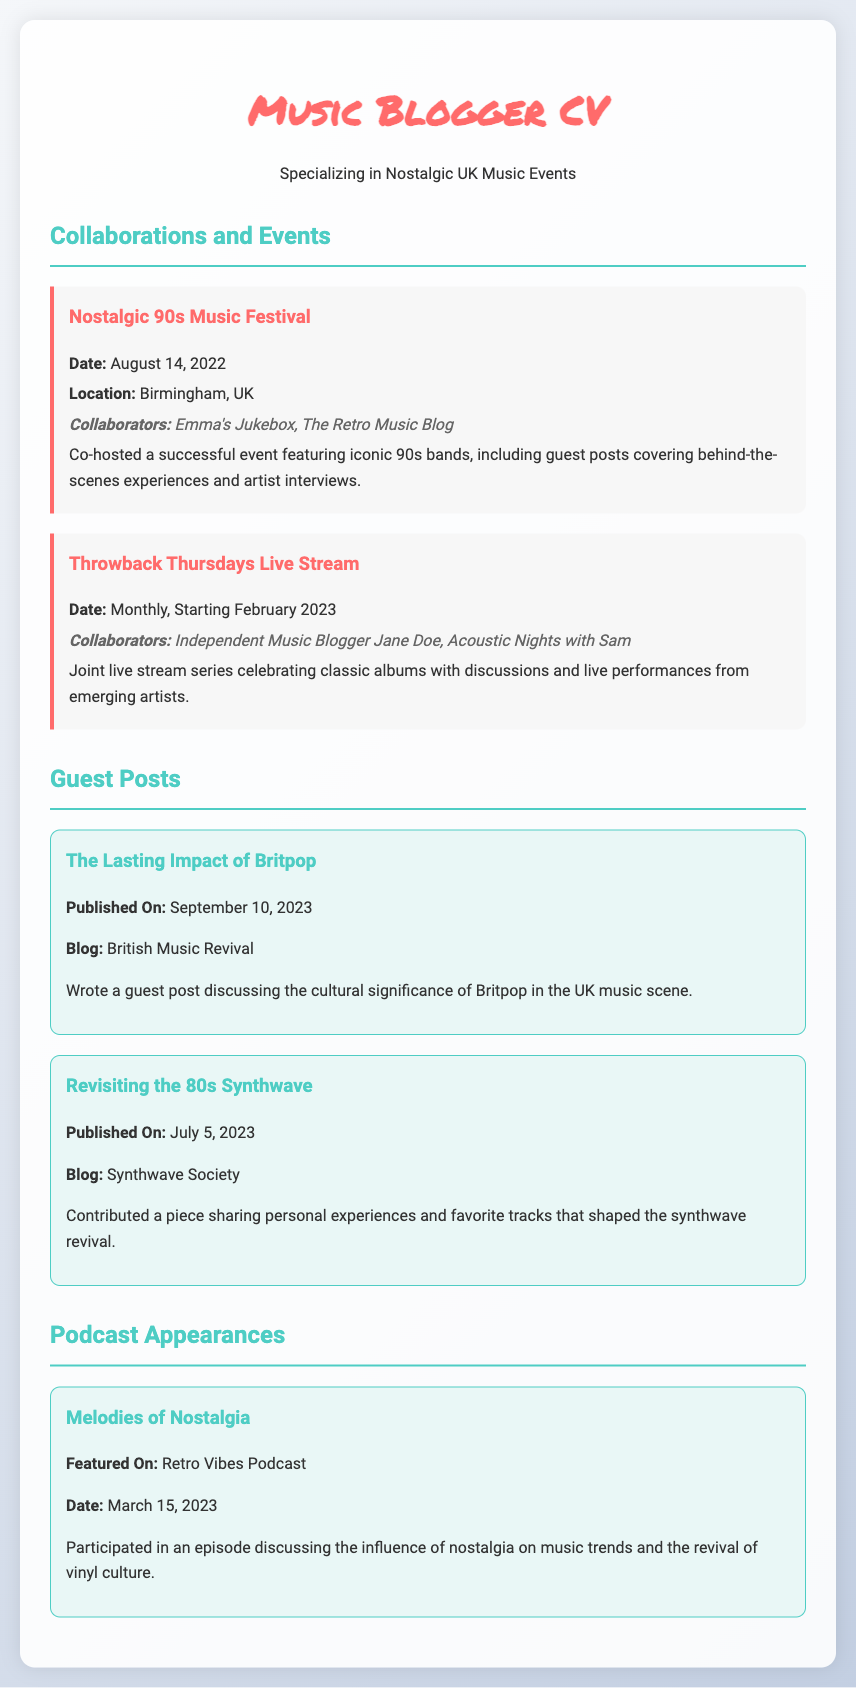What is the title of the document? The title of the document is the main heading at the top, which is "Music Blogger CV - Nostalgic UK Events."
Answer: Music Blogger CV - Nostalgic UK Events When was the Nostalgic 90s Music Festival held? The date is explicitly mentioned in the collaboration section referring to the Nostalgic 90s Music Festival, listed as August 14, 2022.
Answer: August 14, 2022 Who were the collaborators for the Throwback Thursdays Live Stream? The names of the collaborators are listed in the event description for Throwback Thursdays Live Stream as "Independent Music Blogger Jane Doe, Acoustic Nights with Sam."
Answer: Independent Music Blogger Jane Doe, Acoustic Nights with Sam What was the published date of the guest post about Britpop? The document states that the guest post titled "The Lasting Impact of Britpop" was published on September 10, 2023.
Answer: September 10, 2023 Which blog featured the guest post on Synthwave? The blog that published the guest post on Synthwave is mentioned as "Synthwave Society."
Answer: Synthwave Society How many podcast appearances are mentioned? The document lists that there is one podcast appearance, specifically for the "Melodies of Nostalgia."
Answer: One What type of event was co-hosted on August 14, 2022? According to the collaboration section, the event co-hosted on this date was a festival, specifically a nostalgic 90s music festival.
Answer: Festival What is the main topic of discussion in the podcast "Melodies of Nostalgia"? The document highlights that the main topic discussed in the podcast was the influence of nostalgia on music trends and the revival of vinyl culture.
Answer: Influence of nostalgia on music trends What is the focus of the live stream series initiated in February 2023? The focus of the live stream series is explicitly mentioned as celebrating classic albums with discussions and live performances from emerging artists.
Answer: Classic albums 